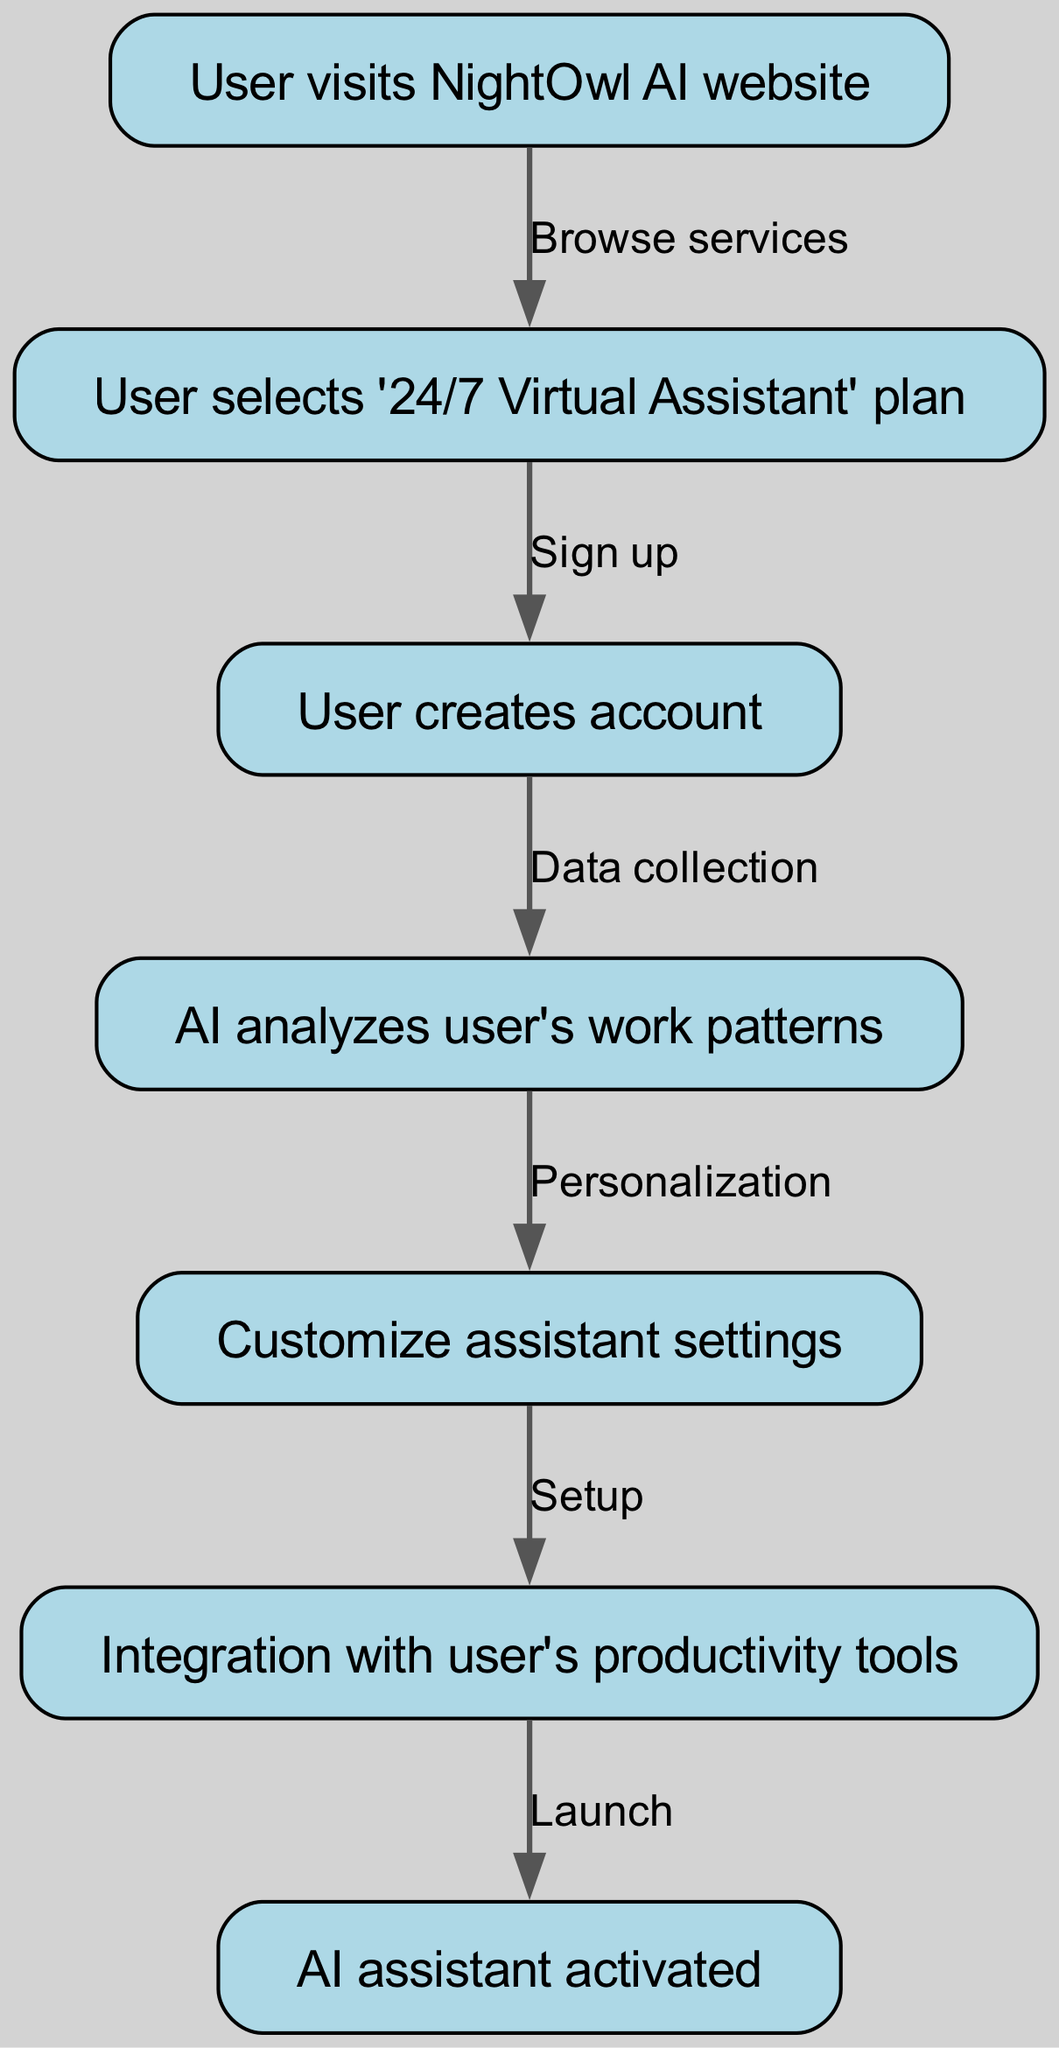What is the first step in the onboarding flow? The first step in the onboarding flow is represented by node 1, which indicates that the user visits the NightOwl AI website.
Answer: User visits NightOwl AI website How many nodes are there in the flow chart? The flow chart contains a total of 7 nodes that represent various steps in the customer onboarding process.
Answer: 7 What is the relationship between node 2 and node 3? Node 2 indicates the user selects the '24/7 Virtual Assistant' plan, and the edge going to node 3 signifies the action of signing up, establishing a clear flow from selecting the plan to creating an account.
Answer: Sign up What is the last action taken in the onboarding process? The last action in the onboarding process is indicated by node 7, where the AI assistant is activated, concluding the flow.
Answer: AI assistant activated What happens after the user creates an account? After the user creates an account (node 3), the next step involves data collection, where the AI analyzes the user's work patterns as indicated by edge from node 3 to node 4.
Answer: Data collection What is the purpose of the edge between node 4 and node 5? The edge between node 4 and node 5 represents the process of personalization, indicating that the AI uses collected data to customize assistant settings for the user.
Answer: Personalization How many edges are present in the diagram? The diagram features 6 edges that connect the various nodes and illustrate the flow from one step to the next in the onboarding process.
Answer: 6 What action is required to integrate with productivity tools? The action required to integrate with productivity tools is setup, represented in the flow when customization of assistant settings is completed in node 5 and leads to node 6.
Answer: Setup What does the AI analyze in step 4? In step 4, the AI analyzes the user's work patterns, which helps in the personalization process in the subsequent steps.
Answer: User's work patterns 